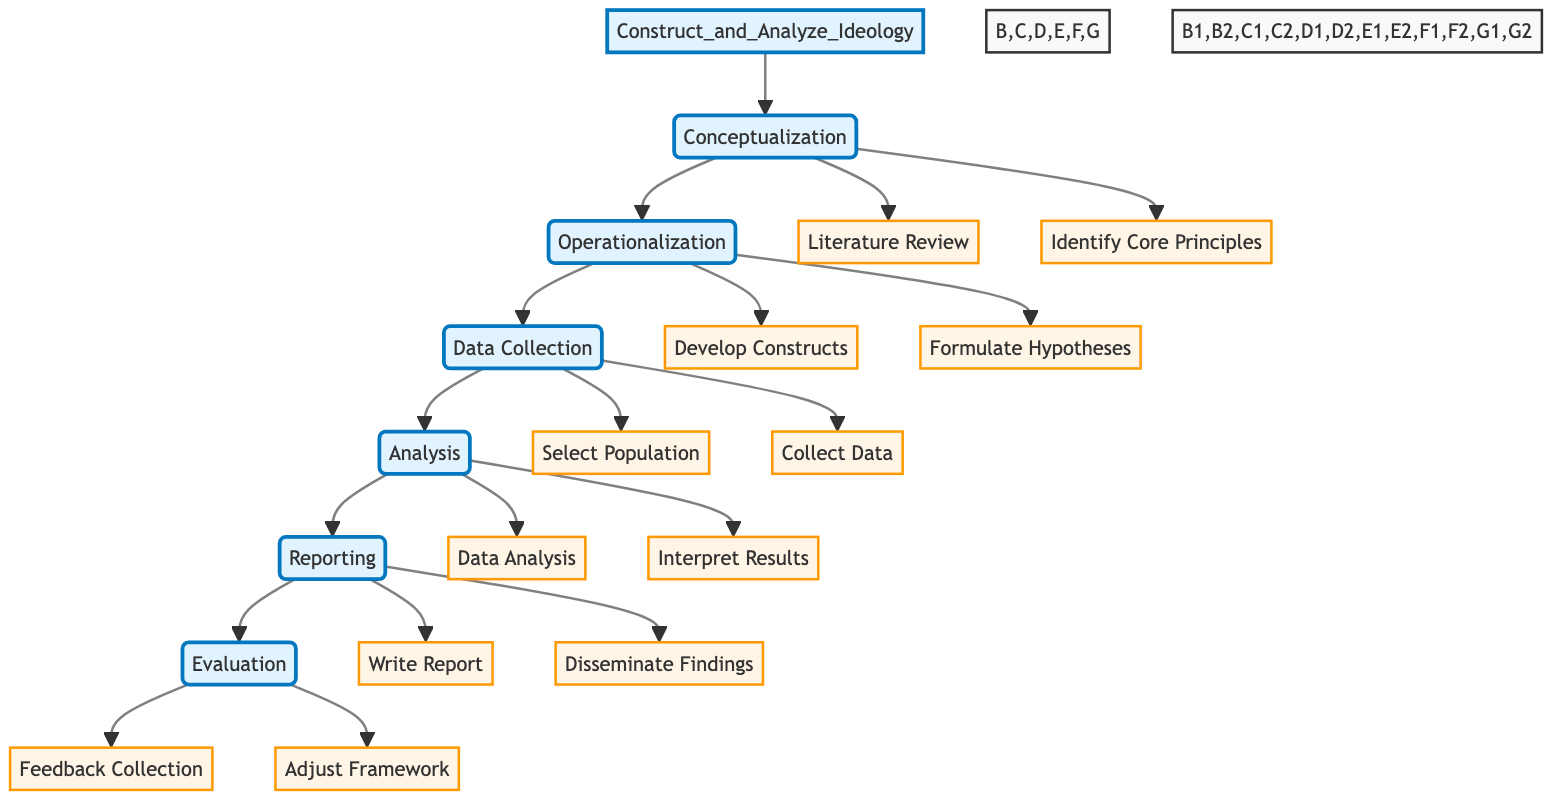What is the first step in the process? The diagram shows "Conceptualization" as the first step following "Construct_and_Analyze_Ideology".
Answer: Conceptualization How many main steps are there in the diagram? By counting the nodes, there are six main steps listed in the diagram: Conceptualization, Operationalization, Data Collection, Analysis, Reporting, Evaluation.
Answer: Six What task comes after "Data Collection"? The flowchart indicates that after "Data Collection", the next step is "Analysis".
Answer: Analysis What are the sub-elements of "Conceptualization"? The diagram specifies that "Literature Review" and "Identify Core Principles" are the sub-elements under "Conceptualization".
Answer: Literature Review, Identify Core Principles Which step includes the task "Write Report"? In the flowchart, "Write Report" is a task that belongs to the "Reporting" step.
Answer: Reporting How do the tasks in "Evaluation" relate to the overall process? The tasks in "Evaluation", which are "Feedback Collection" and "Adjust Framework", serve to assess and refine the research based on stakeholder feedback, thus closing the loop in the process.
Answer: Feedback Collection, Adjust Framework What resources are utilized in "Data Analysis"? The resources for "Data Analysis" are listed as "SPSS", "R", and "Python" in the diagram.
Answer: SPSS, R, Python What is the relationship between "Operationalization" and "Conceptualization"? "Operationalization" is dependent on "Conceptualization" as it follows directly after, indicating that measurements stem from the concepts defined earlier.
Answer: Dependent What is the last step in the flowchart? The final step specified in the flowchart is "Evaluation".
Answer: Evaluation 